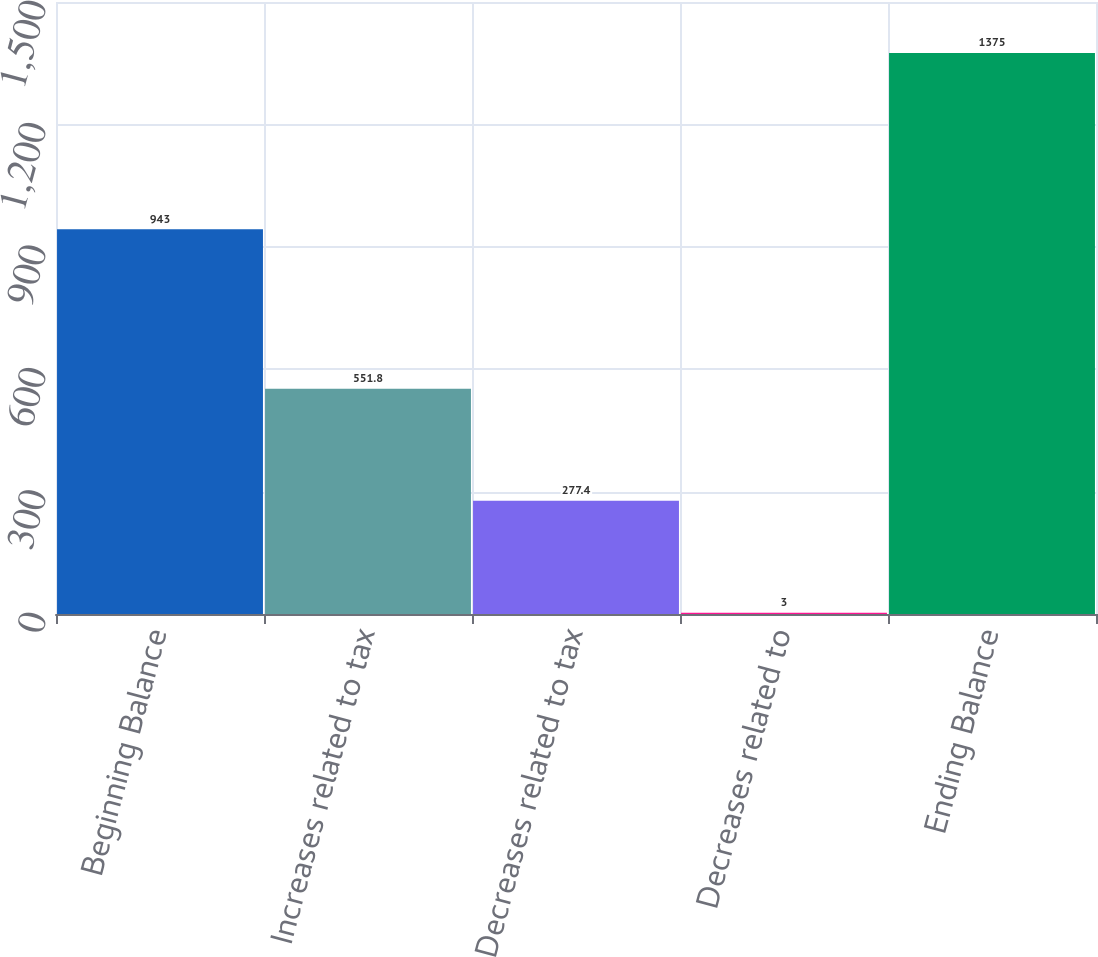Convert chart to OTSL. <chart><loc_0><loc_0><loc_500><loc_500><bar_chart><fcel>Beginning Balance<fcel>Increases related to tax<fcel>Decreases related to tax<fcel>Decreases related to<fcel>Ending Balance<nl><fcel>943<fcel>551.8<fcel>277.4<fcel>3<fcel>1375<nl></chart> 